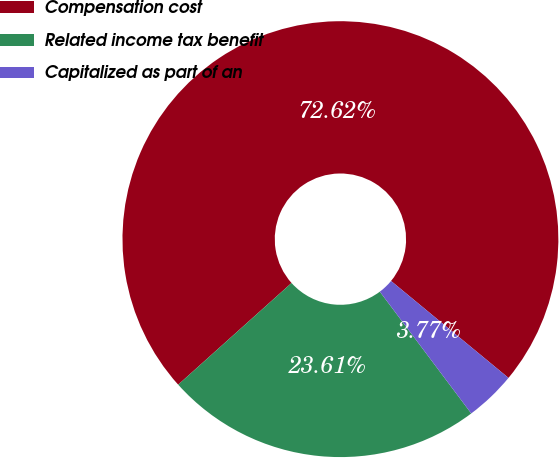Convert chart to OTSL. <chart><loc_0><loc_0><loc_500><loc_500><pie_chart><fcel>Compensation cost<fcel>Related income tax benefit<fcel>Capitalized as part of an<nl><fcel>72.62%<fcel>23.61%<fcel>3.77%<nl></chart> 